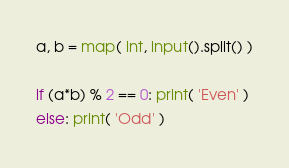<code> <loc_0><loc_0><loc_500><loc_500><_Python_>a, b = map( int, input().split() )

if (a*b) % 2 == 0: print( 'Even' )
else: print( 'Odd' )</code> 